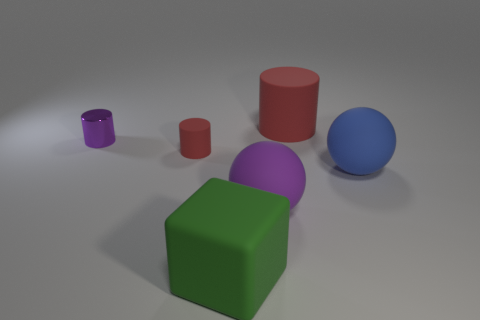Does the purple sphere have the same size as the blue rubber object?
Ensure brevity in your answer.  Yes. What number of spheres are blue rubber objects or small purple metallic things?
Your response must be concise. 1. How many big things are both behind the small matte thing and in front of the blue ball?
Your answer should be compact. 0. There is a purple shiny object; is it the same size as the red rubber thing in front of the large cylinder?
Your answer should be very brief. Yes. Are there any large red matte cylinders that are on the right side of the red cylinder on the right side of the red rubber cylinder that is on the left side of the large red cylinder?
Offer a terse response. No. What is the material of the big ball that is on the right side of the cylinder to the right of the green object?
Make the answer very short. Rubber. What is the large thing that is both in front of the big blue object and behind the big green matte thing made of?
Offer a terse response. Rubber. Is there a big purple object of the same shape as the big blue object?
Keep it short and to the point. Yes. There is a big blue rubber sphere that is in front of the tiny red object; is there a tiny purple shiny object that is right of it?
Offer a very short reply. No. How many tiny purple things have the same material as the blue thing?
Provide a short and direct response. 0. 